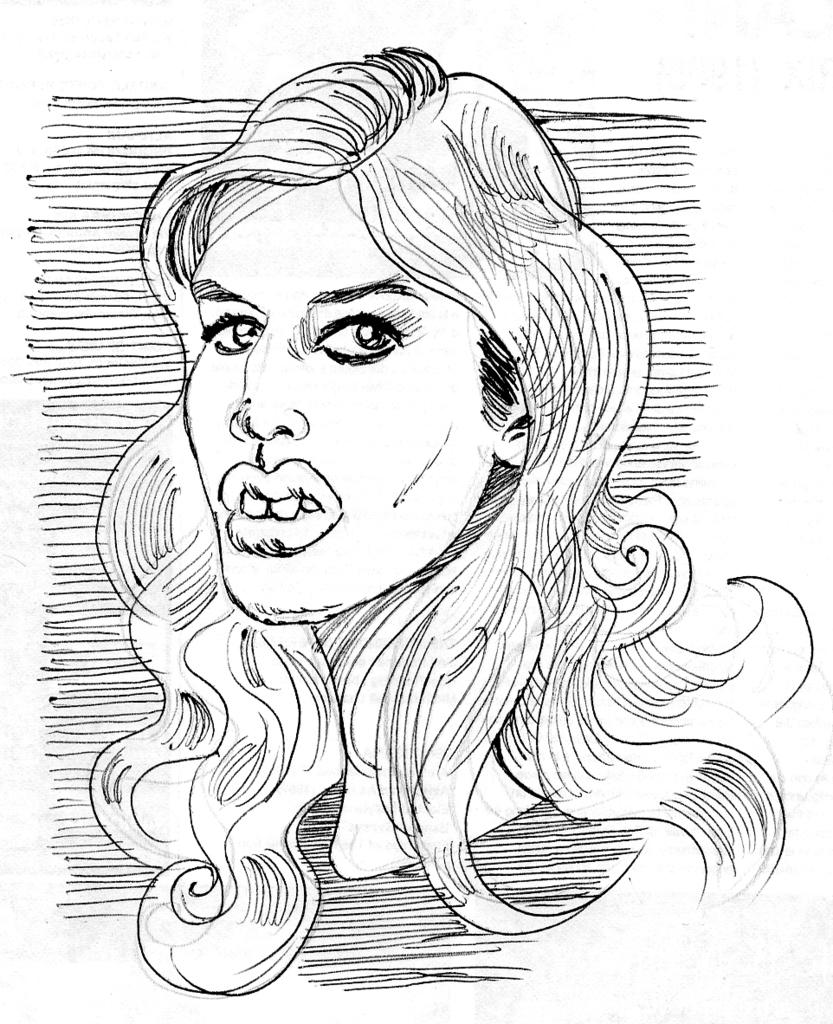What is depicted in the image? There is a sketch of a woman in the image. Can you describe the subject of the sketch? The sketch is of a woman. What is the price of the horse in the image? There is no horse present in the image, only a sketch of a woman. 